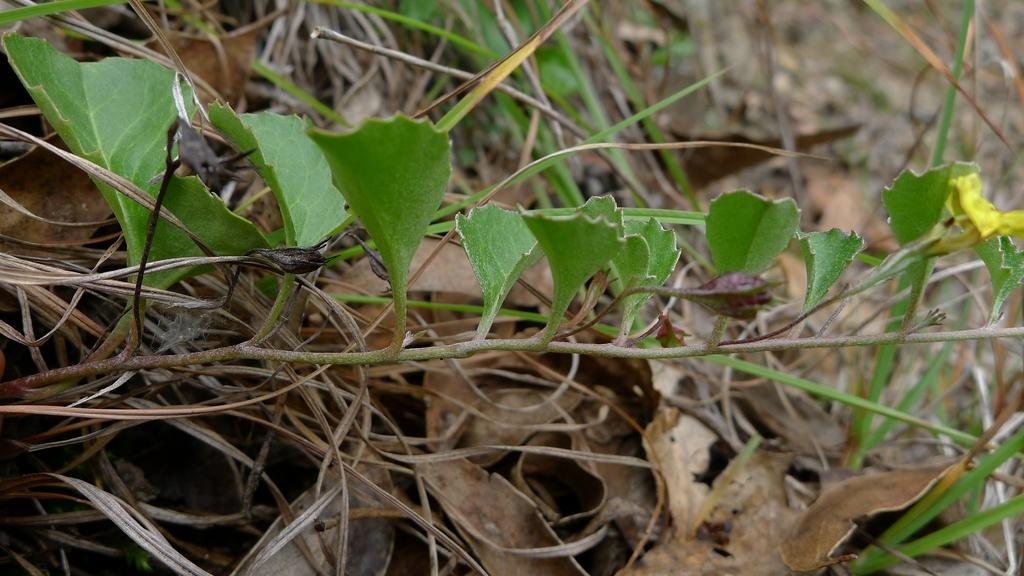What is the main subject of the image? The main subject of the image is a stem with leaves and a flower. Can you describe the flower on the stem? Yes, there is a flower on the stem. What can be seen in the background of the image? In the background of the image, there are dry leaves and grass visible. What type of wall can be seen in the image? There is no wall present in the image; it features a stem with leaves and a flower, along with dry leaves and grass in the background. How does the flower blow in the wind in the image? The image does not depict the flower blowing in the wind; it is stationary on the stem. 